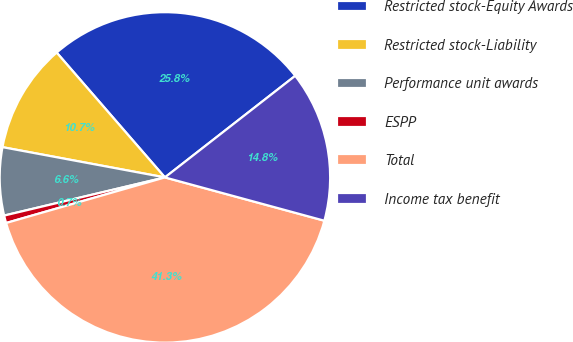Convert chart. <chart><loc_0><loc_0><loc_500><loc_500><pie_chart><fcel>Restricted stock-Equity Awards<fcel>Restricted stock-Liability<fcel>Performance unit awards<fcel>ESPP<fcel>Total<fcel>Income tax benefit<nl><fcel>25.83%<fcel>10.7%<fcel>6.64%<fcel>0.74%<fcel>41.33%<fcel>14.76%<nl></chart> 